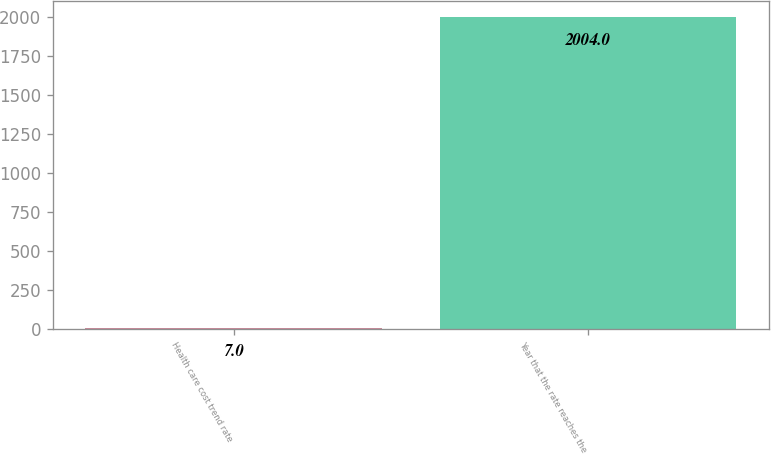<chart> <loc_0><loc_0><loc_500><loc_500><bar_chart><fcel>Health care cost trend rate<fcel>Year that the rate reaches the<nl><fcel>7<fcel>2004<nl></chart> 